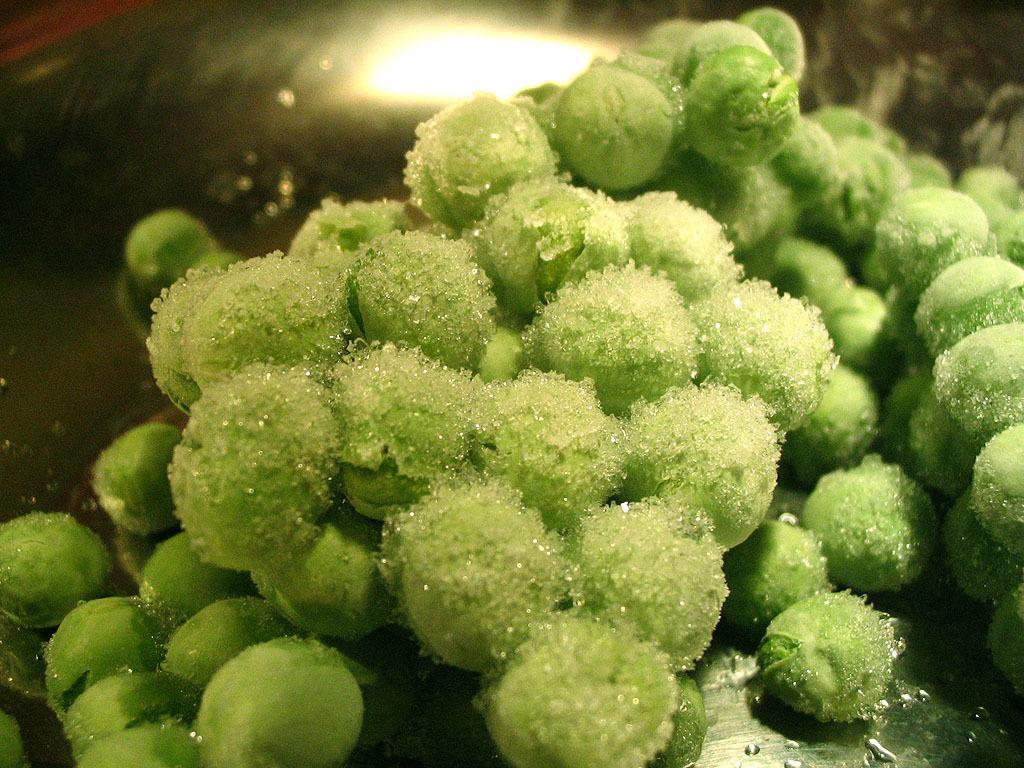Can you describe this image briefly? In this image we can see a food item. In the back there is a light. 